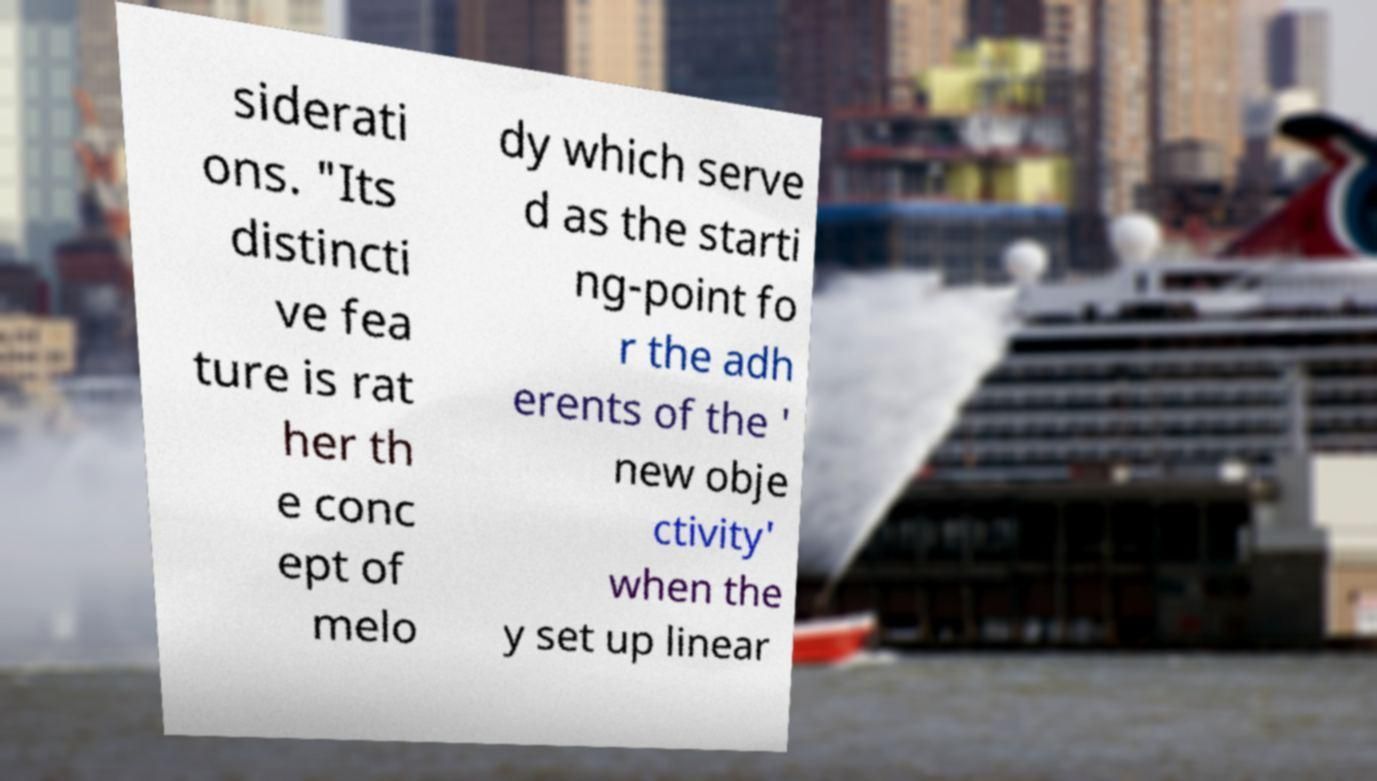I need the written content from this picture converted into text. Can you do that? siderati ons. "Its distincti ve fea ture is rat her th e conc ept of melo dy which serve d as the starti ng-point fo r the adh erents of the ' new obje ctivity' when the y set up linear 